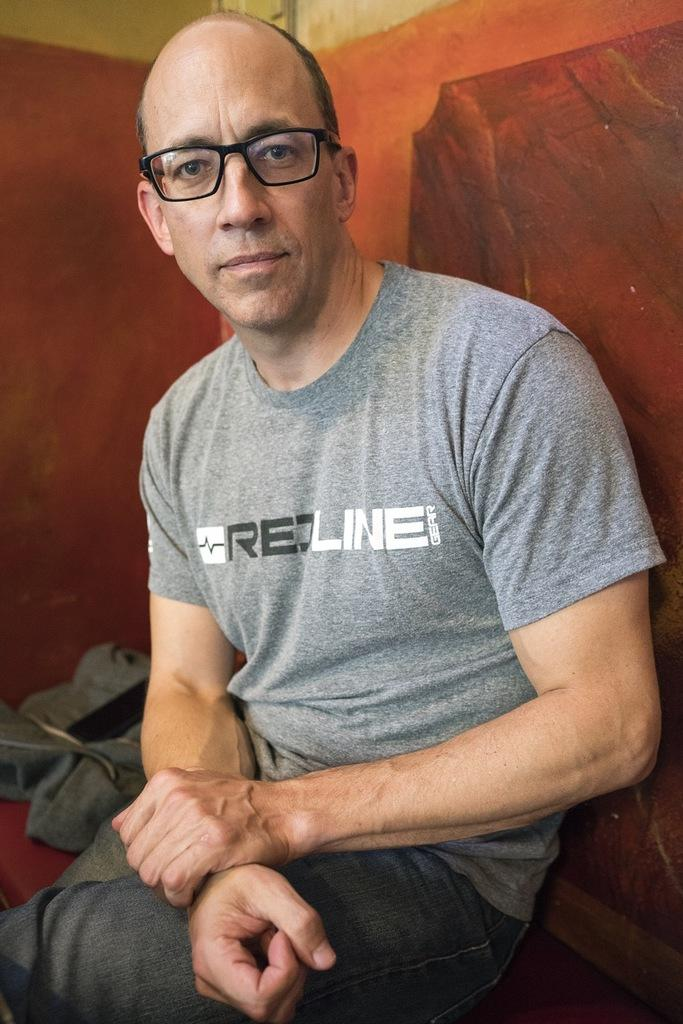What is the main subject of the image? There is a person in the image. What is the person wearing on their upper body? The person is wearing a grey T-shirt. What is the person wearing on their lower body? The person is wearing black pants. What accessory is the person wearing on their face? The person is wearing spectacles. What piece of furniture is the person sitting on? The person is sitting on a sofa. What can be seen behind the person in the image? There is a wall in the background of the image. What design is the person's mom showing in the image? There is no mention of a mom or a design in the image; it only features a person sitting on a sofa. 